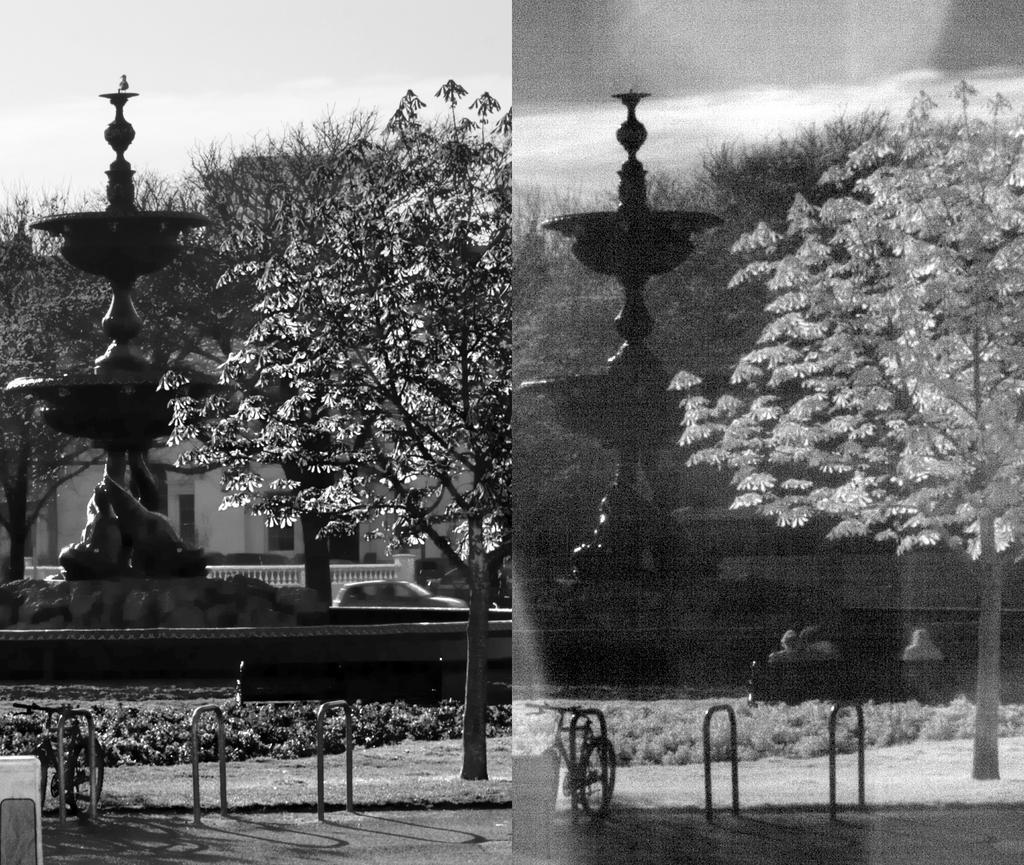In one or two sentences, can you explain what this image depicts? In this image we can see a collage of same picture, there is a fountain, bicycle on the road, iron rods, tree an in the background there is a building, trees and sky. 